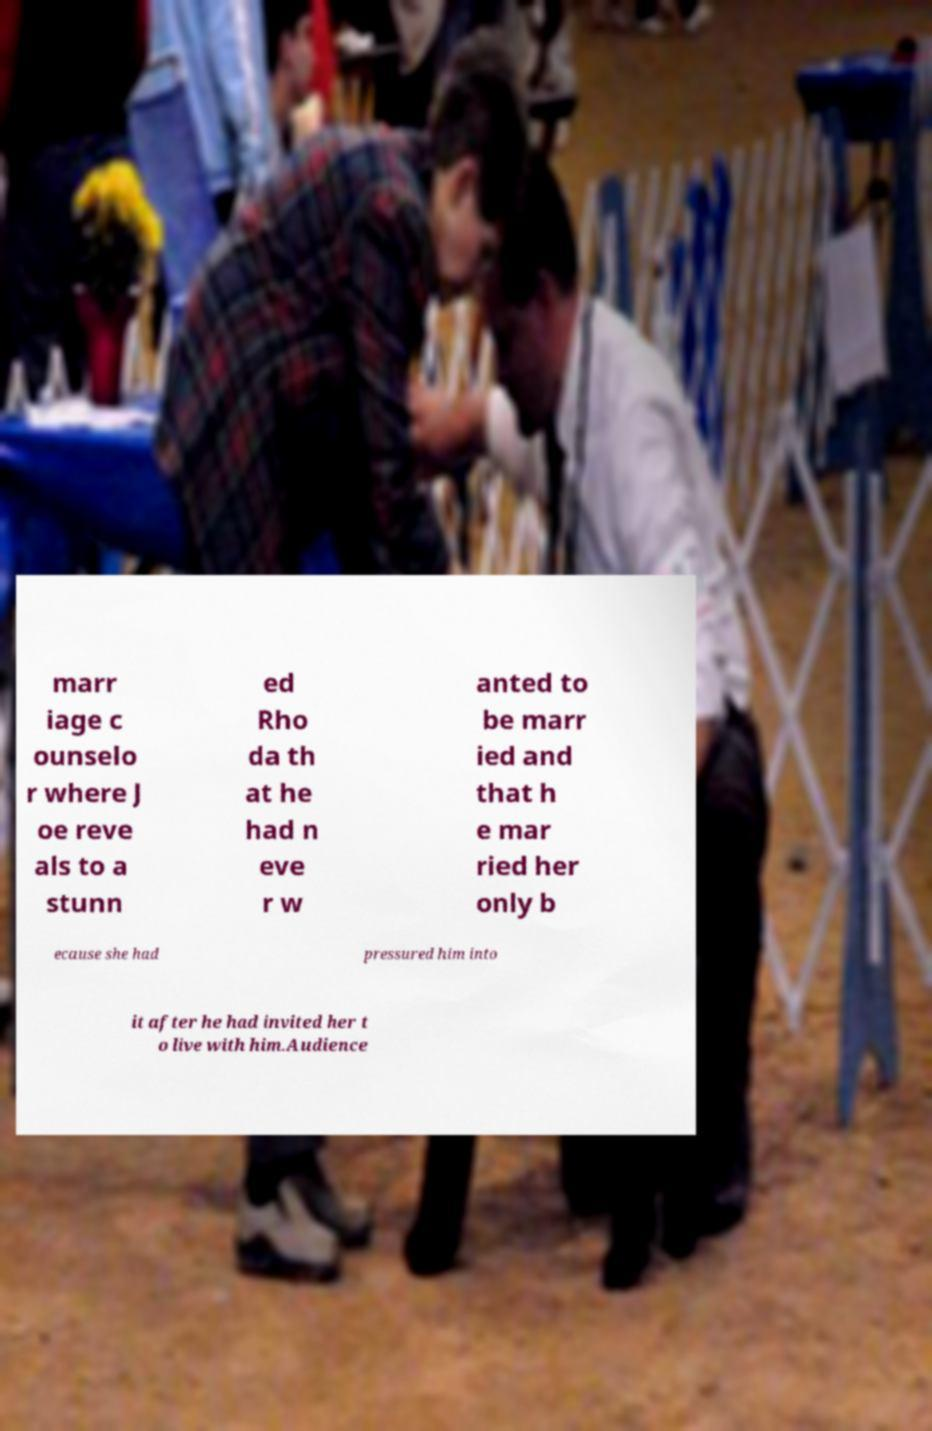Could you assist in decoding the text presented in this image and type it out clearly? marr iage c ounselo r where J oe reve als to a stunn ed Rho da th at he had n eve r w anted to be marr ied and that h e mar ried her only b ecause she had pressured him into it after he had invited her t o live with him.Audience 